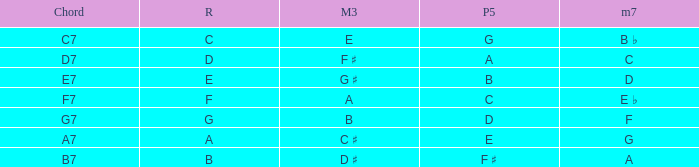What is the Chord with a Major that is third of e? C7. 